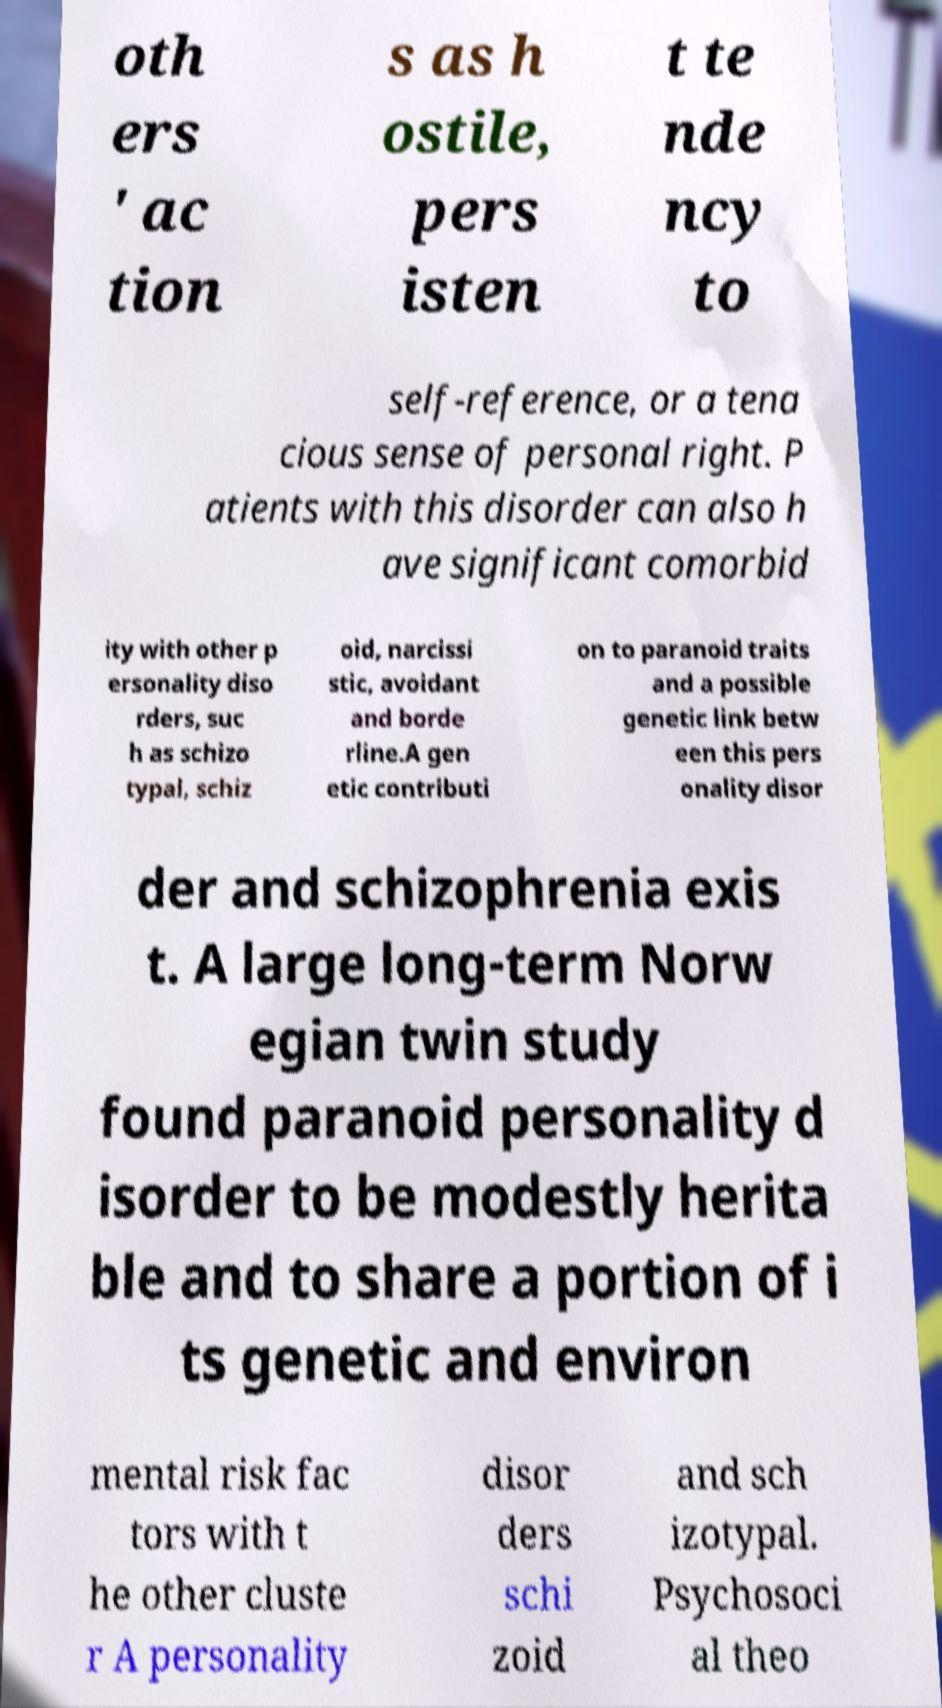Could you assist in decoding the text presented in this image and type it out clearly? oth ers ' ac tion s as h ostile, pers isten t te nde ncy to self-reference, or a tena cious sense of personal right. P atients with this disorder can also h ave significant comorbid ity with other p ersonality diso rders, suc h as schizo typal, schiz oid, narcissi stic, avoidant and borde rline.A gen etic contributi on to paranoid traits and a possible genetic link betw een this pers onality disor der and schizophrenia exis t. A large long-term Norw egian twin study found paranoid personality d isorder to be modestly herita ble and to share a portion of i ts genetic and environ mental risk fac tors with t he other cluste r A personality disor ders schi zoid and sch izotypal. Psychosoci al theo 